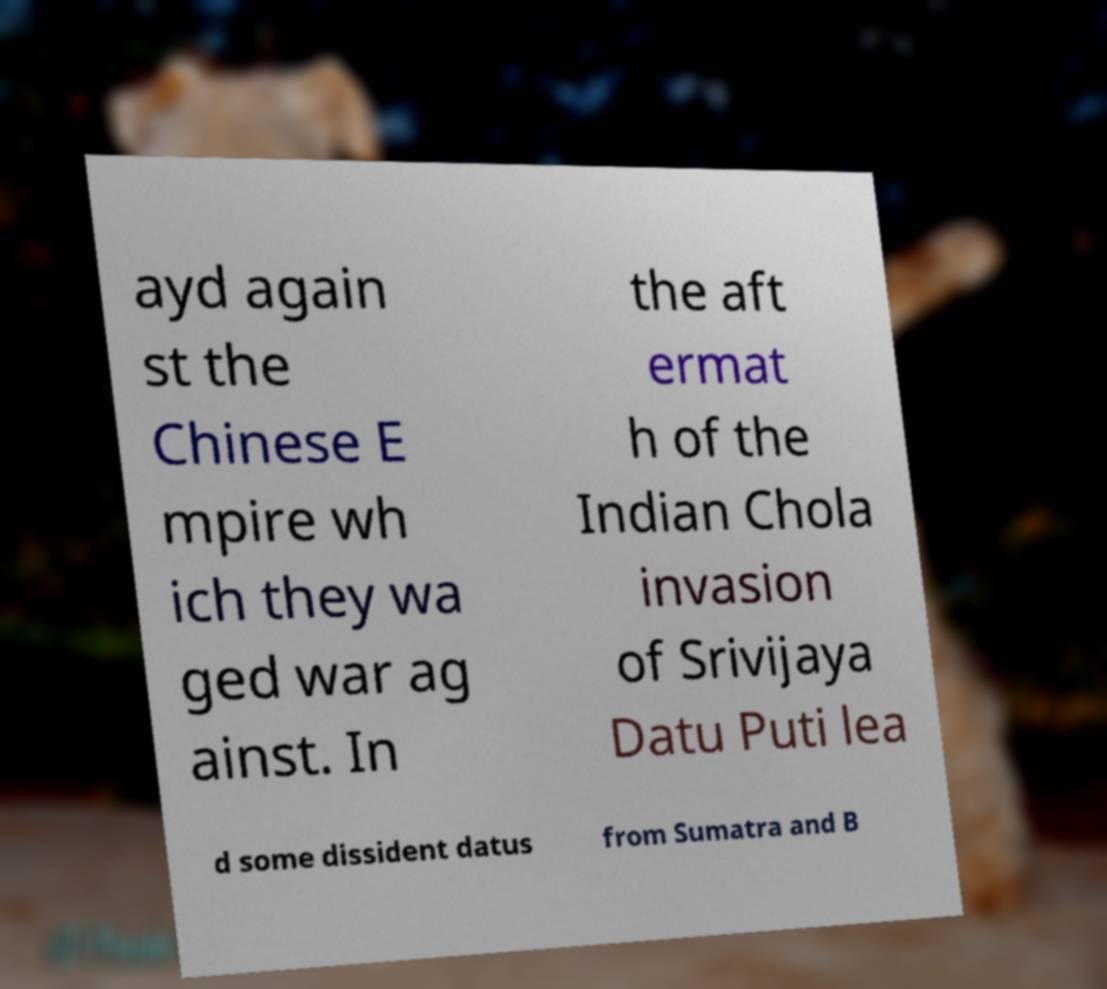Can you accurately transcribe the text from the provided image for me? ayd again st the Chinese E mpire wh ich they wa ged war ag ainst. In the aft ermat h of the Indian Chola invasion of Srivijaya Datu Puti lea d some dissident datus from Sumatra and B 